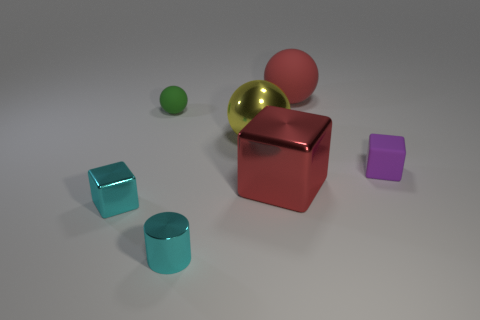Does the purple rubber thing have the same shape as the green thing?
Keep it short and to the point. No. What number of objects are either things behind the yellow metallic object or big yellow shiny objects?
Give a very brief answer. 3. There is a big object in front of the cube right of the rubber sphere that is right of the red cube; what is its shape?
Your answer should be compact. Cube. There is a red thing that is the same material as the big yellow ball; what is its shape?
Your answer should be very brief. Cube. What is the size of the purple matte object?
Keep it short and to the point. Small. Do the green thing and the red block have the same size?
Your answer should be compact. No. What number of objects are either small objects that are right of the cyan shiny cylinder or small objects that are on the left side of the yellow metallic thing?
Your response must be concise. 4. There is a tiny block that is behind the cyan thing behind the tiny cyan cylinder; how many small cubes are left of it?
Offer a very short reply. 1. There is a red object that is in front of the purple rubber cube; what size is it?
Provide a short and direct response. Large. What number of green shiny objects have the same size as the red ball?
Give a very brief answer. 0. 